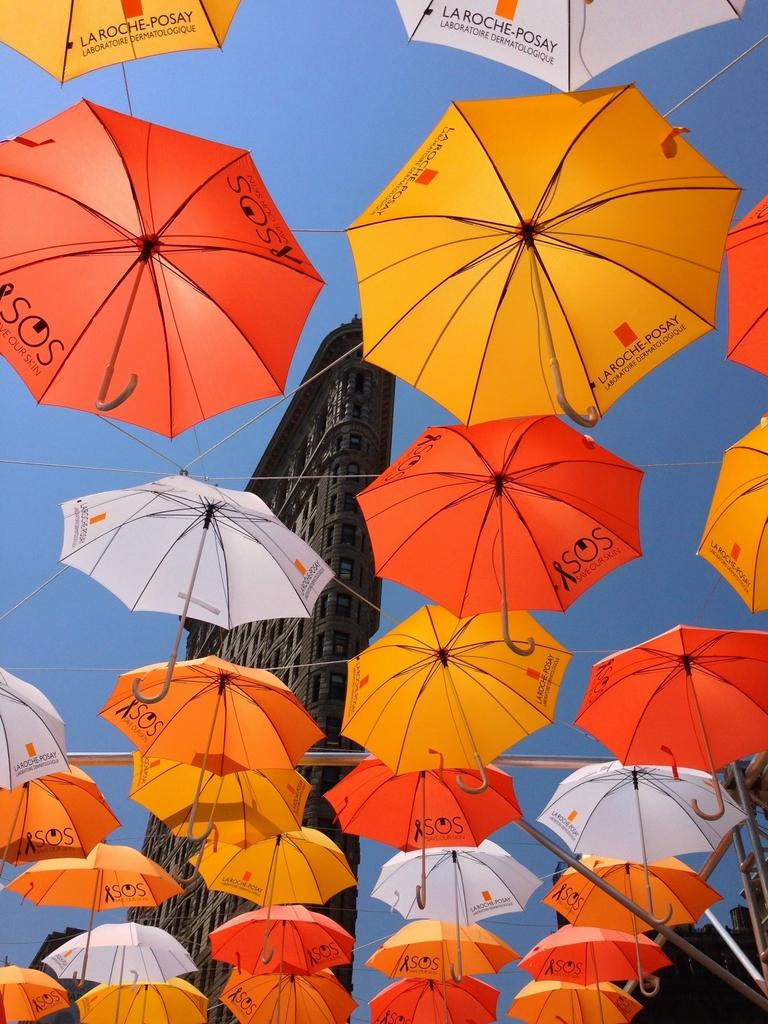Where was the image taken? The image was taken outdoors. What can be seen in the background of the image? The sky and buildings are visible in the background of the image. What is the main subject in the middle of the image? There are many umbrellas in the middle of the image. What type of shoes are the pigs wearing in the image? There are no pigs or shoes present in the image. What kind of suit is the pig wearing in the image? There are no pigs or suits present in the image. 